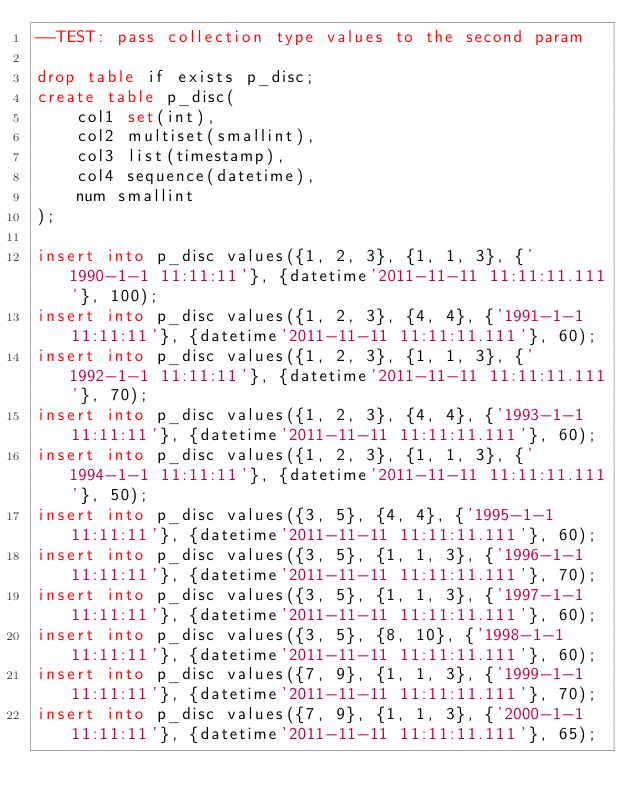<code> <loc_0><loc_0><loc_500><loc_500><_SQL_>--TEST: pass collection type values to the second param

drop table if exists p_disc;
create table p_disc(
	col1 set(int),
	col2 multiset(smallint), 
	col3 list(timestamp),
	col4 sequence(datetime),
	num smallint
);

insert into p_disc values({1, 2, 3}, {1, 1, 3}, {'1990-1-1 11:11:11'}, {datetime'2011-11-11 11:11:11.111'}, 100);
insert into p_disc values({1, 2, 3}, {4, 4}, {'1991-1-1 11:11:11'}, {datetime'2011-11-11 11:11:11.111'}, 60);
insert into p_disc values({1, 2, 3}, {1, 1, 3}, {'1992-1-1 11:11:11'}, {datetime'2011-11-11 11:11:11.111'}, 70);
insert into p_disc values({1, 2, 3}, {4, 4}, {'1993-1-1 11:11:11'}, {datetime'2011-11-11 11:11:11.111'}, 60);
insert into p_disc values({1, 2, 3}, {1, 1, 3}, {'1994-1-1 11:11:11'}, {datetime'2011-11-11 11:11:11.111'}, 50);
insert into p_disc values({3, 5}, {4, 4}, {'1995-1-1 11:11:11'}, {datetime'2011-11-11 11:11:11.111'}, 60);
insert into p_disc values({3, 5}, {1, 1, 3}, {'1996-1-1 11:11:11'}, {datetime'2011-11-11 11:11:11.111'}, 70);
insert into p_disc values({3, 5}, {1, 1, 3}, {'1997-1-1 11:11:11'}, {datetime'2011-11-11 11:11:11.111'}, 60);
insert into p_disc values({3, 5}, {8, 10}, {'1998-1-1 11:11:11'}, {datetime'2011-11-11 11:11:11.111'}, 60);
insert into p_disc values({7, 9}, {1, 1, 3}, {'1999-1-1 11:11:11'}, {datetime'2011-11-11 11:11:11.111'}, 70);
insert into p_disc values({7, 9}, {1, 1, 3}, {'2000-1-1 11:11:11'}, {datetime'2011-11-11 11:11:11.111'}, 65);</code> 